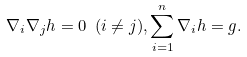Convert formula to latex. <formula><loc_0><loc_0><loc_500><loc_500>\nabla _ { i } \nabla _ { j } h = 0 \ ( i \ne j ) , \sum _ { i = 1 } ^ { n } \nabla _ { i } h = g .</formula> 